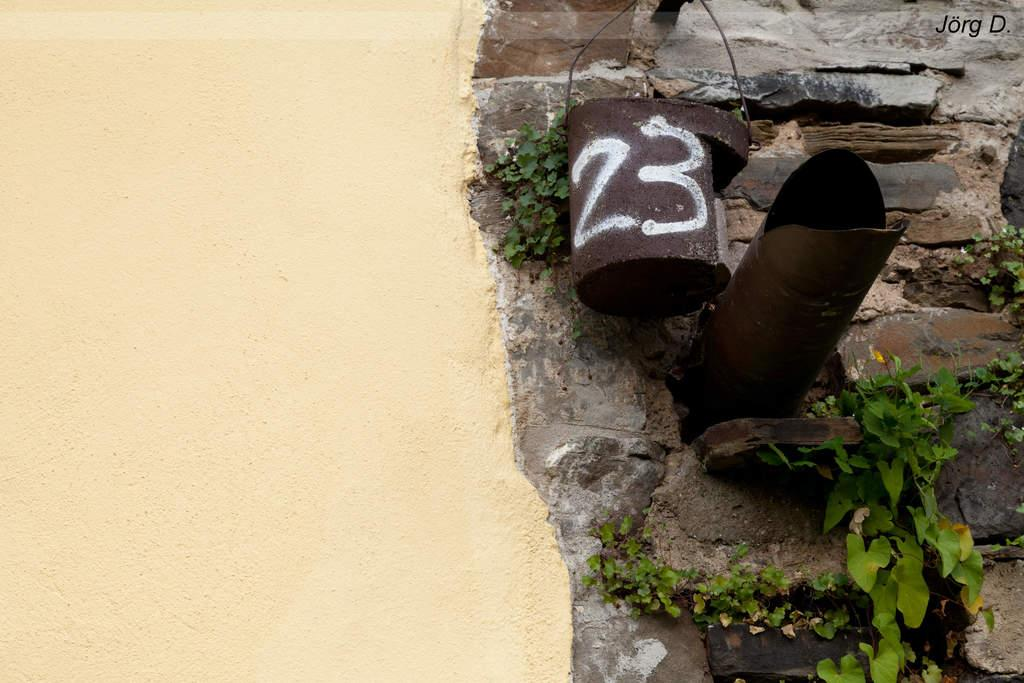What type of wall can be seen on the left side of the image? There is a cream-colored wall in the image. What type of wall can be seen on the right side of the image? There is a wall made of rocks in the image. What type of vegetation is present in the image? There are green plants in the image. What color are the objects on the wall? There are brown-colored objects on the wall. Can you see a river flowing through the yard in the image? There is no yard or river present in the image. What type of pancake is being served on the wall in the image? There is no pancake present in the image; the objects on the wall are brown-colored. 